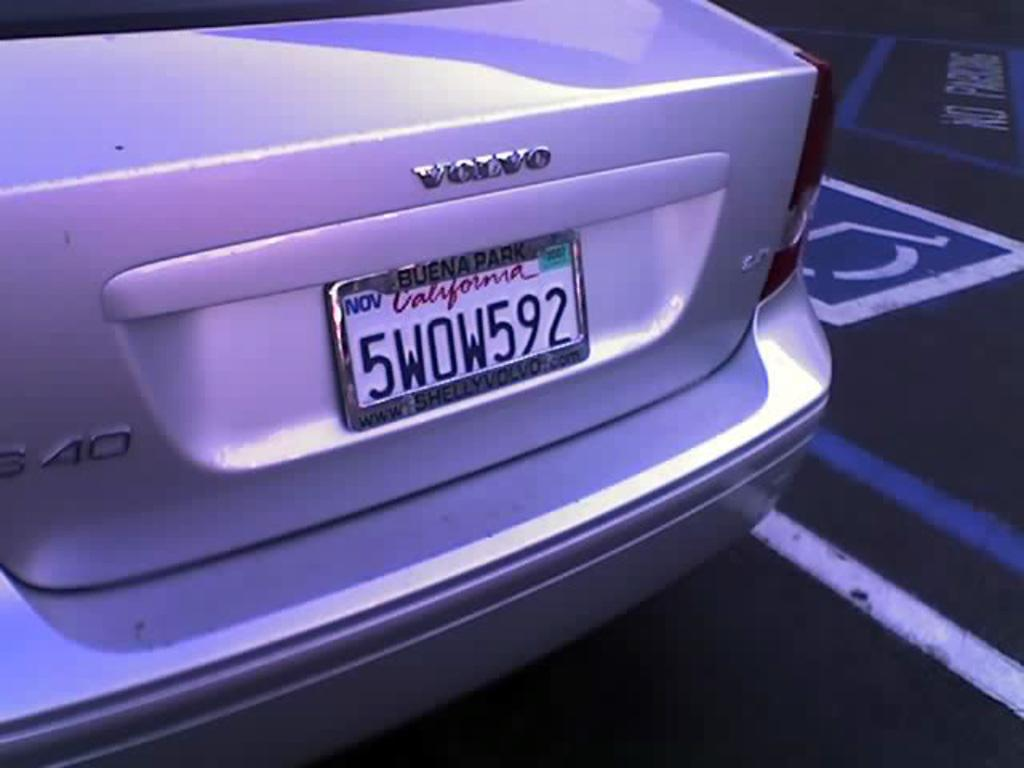Provide a one-sentence caption for the provided image. The license plate is 5WOW592 and in the California state. 